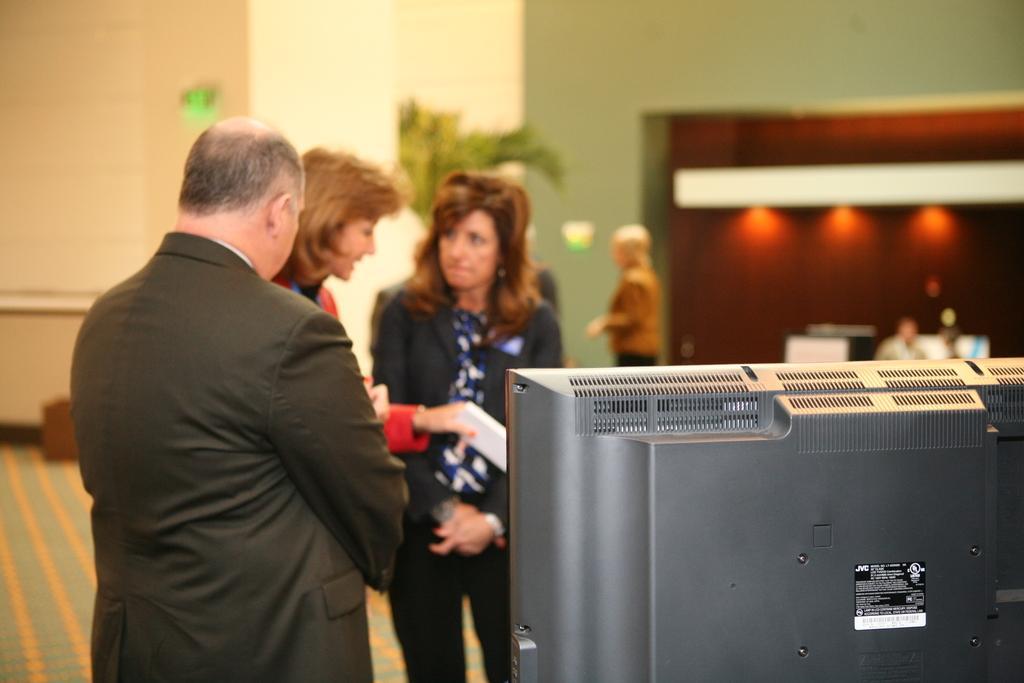Describe this image in one or two sentences. In this picture, we see the man and two women are standing. The woman in red blazer is holding the papers in her hand. In the right bottom of the picture, we see the monitor. Behind them, we see the woman is standing. On the right side, we see a man is sitting on the chair. In the background, we see a flower pot and a wall in white and green color. This picture is blurred in the background. At the bottom, we see a carpet in green and yellow color. 